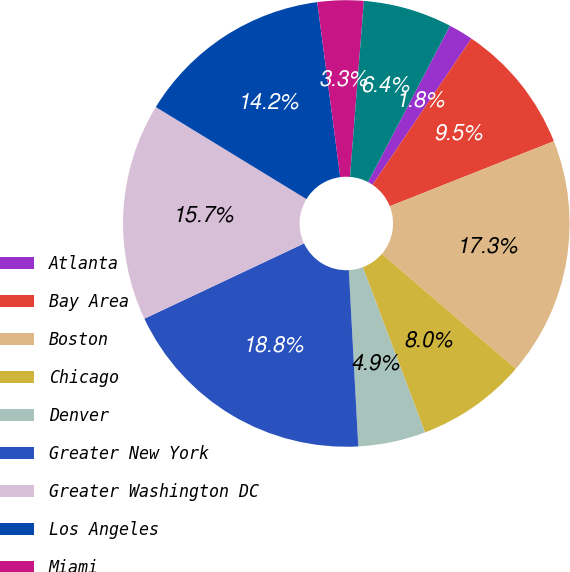Convert chart to OTSL. <chart><loc_0><loc_0><loc_500><loc_500><pie_chart><fcel>Atlanta<fcel>Bay Area<fcel>Boston<fcel>Chicago<fcel>Denver<fcel>Greater New York<fcel>Greater Washington DC<fcel>Los Angeles<fcel>Miami<fcel>Philadelphia<nl><fcel>1.78%<fcel>9.53%<fcel>17.29%<fcel>7.98%<fcel>4.88%<fcel>18.84%<fcel>15.74%<fcel>14.19%<fcel>3.33%<fcel>6.43%<nl></chart> 